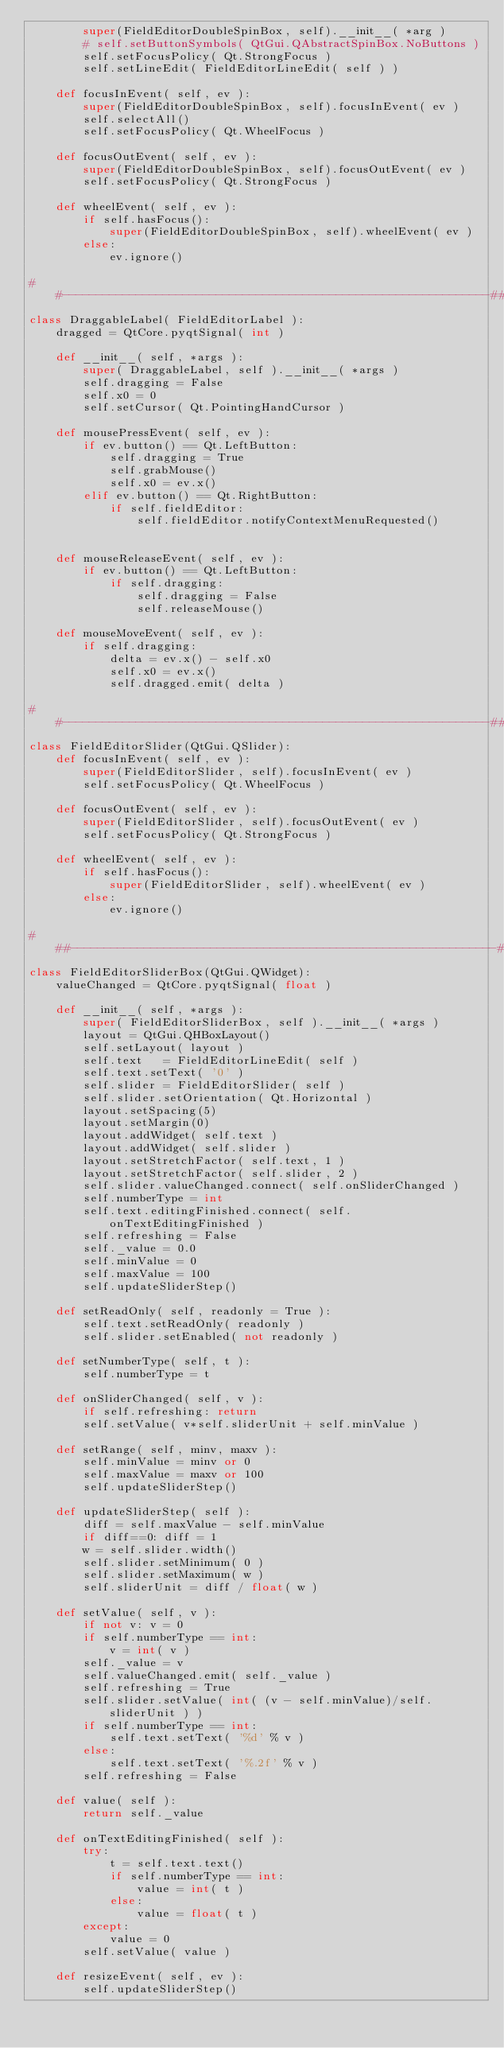Convert code to text. <code><loc_0><loc_0><loc_500><loc_500><_Python_>		super(FieldEditorDoubleSpinBox, self).__init__( *arg )
		# self.setButtonSymbols( QtGui.QAbstractSpinBox.NoButtons )
		self.setFocusPolicy( Qt.StrongFocus )
		self.setLineEdit( FieldEditorLineEdit( self ) )

	def focusInEvent( self, ev ):
		super(FieldEditorDoubleSpinBox, self).focusInEvent( ev )
		self.selectAll()
		self.setFocusPolicy( Qt.WheelFocus )

	def focusOutEvent( self, ev ):
		super(FieldEditorDoubleSpinBox, self).focusOutEvent( ev )
		self.setFocusPolicy( Qt.StrongFocus )
		
	def wheelEvent( self, ev ):
		if self.hasFocus():
			super(FieldEditorDoubleSpinBox, self).wheelEvent( ev )
		else:
			ev.ignore()

##----------------------------------------------------------------##
class DraggableLabel( FieldEditorLabel ):
	dragged = QtCore.pyqtSignal( int )

	def __init__( self, *args ):
		super( DraggableLabel, self ).__init__( *args )
		self.dragging = False
		self.x0 = 0
		self.setCursor( Qt.PointingHandCursor )

	def mousePressEvent( self, ev ):
		if ev.button() == Qt.LeftButton:
			self.dragging = True
			self.grabMouse()
			self.x0 = ev.x()
		elif ev.button() == Qt.RightButton:
			if self.fieldEditor:
				self.fieldEditor.notifyContextMenuRequested()
			

	def mouseReleaseEvent( self, ev ):
		if ev.button() == Qt.LeftButton:
			if self.dragging:
				self.dragging = False
				self.releaseMouse()

	def mouseMoveEvent( self, ev ):
		if self.dragging:
			delta = ev.x() - self.x0
			self.x0 = ev.x()
			self.dragged.emit( delta )

##----------------------------------------------------------------##
class FieldEditorSlider(QtGui.QSlider):
	def focusInEvent( self, ev ):
		super(FieldEditorSlider, self).focusInEvent( ev )
		self.setFocusPolicy( Qt.WheelFocus )

	def focusOutEvent( self, ev ):
		super(FieldEditorSlider, self).focusOutEvent( ev )
		self.setFocusPolicy( Qt.StrongFocus )

	def wheelEvent( self, ev ):
		if self.hasFocus():
			super(FieldEditorSlider, self).wheelEvent( ev )
		else:
			ev.ignore()

# ##----------------------------------------------------------------##
class FieldEditorSliderBox(QtGui.QWidget):
	valueChanged = QtCore.pyqtSignal( float )

	def __init__( self, *args ):
		super( FieldEditorSliderBox, self ).__init__( *args )
		layout = QtGui.QHBoxLayout()
		self.setLayout( layout )
		self.text   = FieldEditorLineEdit( self )
		self.text.setText( '0' )
		self.slider = FieldEditorSlider( self )
		self.slider.setOrientation( Qt.Horizontal )		
		layout.setSpacing(5)
		layout.setMargin(0)
		layout.addWidget( self.text )
		layout.addWidget( self.slider )
		layout.setStretchFactor( self.text, 1 )
		layout.setStretchFactor( self.slider, 2 )
		self.slider.valueChanged.connect( self.onSliderChanged )
		self.numberType = int
		self.text.editingFinished.connect( self.onTextEditingFinished )
		self.refreshing = False
		self._value = 0.0
		self.minValue = 0
		self.maxValue = 100
		self.updateSliderStep()

	def setReadOnly( self, readonly = True ):
		self.text.setReadOnly( readonly )
		self.slider.setEnabled( not readonly )

	def setNumberType( self, t ):
		self.numberType = t

	def onSliderChanged( self, v ):
		if self.refreshing: return
		self.setValue( v*self.sliderUnit + self.minValue )

	def setRange( self, minv, maxv ):		
		self.minValue = minv or 0
		self.maxValue = maxv or 100
		self.updateSliderStep()

	def updateSliderStep( self ):
		diff = self.maxValue - self.minValue
		if diff==0: diff = 1
		w = self.slider.width()
		self.slider.setMinimum( 0 )
		self.slider.setMaximum( w )
		self.sliderUnit = diff / float( w )

	def setValue( self, v ):
		if not v: v = 0
		if self.numberType == int:
			v = int( v )
		self._value = v
		self.valueChanged.emit( self._value )
		self.refreshing = True
		self.slider.setValue( int( (v - self.minValue)/self.sliderUnit ) )
		if self.numberType == int:
			self.text.setText( '%d' % v )
		else:
			self.text.setText( '%.2f' % v )
		self.refreshing = False

	def value( self ):
		return self._value

	def onTextEditingFinished( self ):
		try:
			t = self.text.text()
			if self.numberType == int:
				value = int( t )
			else:
				value = float( t )
		except:
			value = 0
		self.setValue( value )

	def resizeEvent( self, ev ):
		self.updateSliderStep()		

</code> 